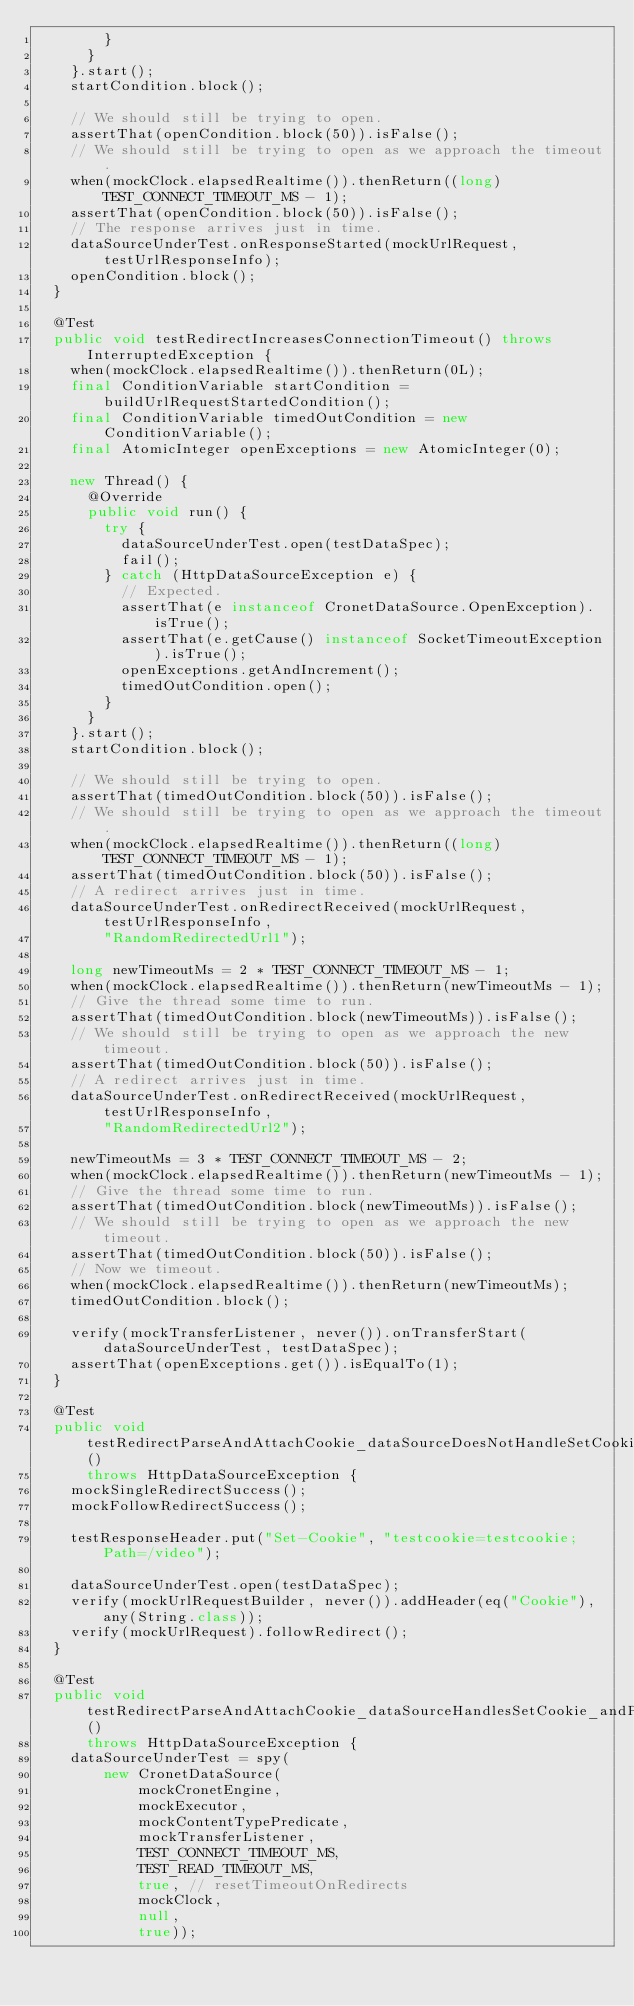Convert code to text. <code><loc_0><loc_0><loc_500><loc_500><_Java_>        }
      }
    }.start();
    startCondition.block();

    // We should still be trying to open.
    assertThat(openCondition.block(50)).isFalse();
    // We should still be trying to open as we approach the timeout.
    when(mockClock.elapsedRealtime()).thenReturn((long) TEST_CONNECT_TIMEOUT_MS - 1);
    assertThat(openCondition.block(50)).isFalse();
    // The response arrives just in time.
    dataSourceUnderTest.onResponseStarted(mockUrlRequest, testUrlResponseInfo);
    openCondition.block();
  }

  @Test
  public void testRedirectIncreasesConnectionTimeout() throws InterruptedException {
    when(mockClock.elapsedRealtime()).thenReturn(0L);
    final ConditionVariable startCondition = buildUrlRequestStartedCondition();
    final ConditionVariable timedOutCondition = new ConditionVariable();
    final AtomicInteger openExceptions = new AtomicInteger(0);

    new Thread() {
      @Override
      public void run() {
        try {
          dataSourceUnderTest.open(testDataSpec);
          fail();
        } catch (HttpDataSourceException e) {
          // Expected.
          assertThat(e instanceof CronetDataSource.OpenException).isTrue();
          assertThat(e.getCause() instanceof SocketTimeoutException).isTrue();
          openExceptions.getAndIncrement();
          timedOutCondition.open();
        }
      }
    }.start();
    startCondition.block();

    // We should still be trying to open.
    assertThat(timedOutCondition.block(50)).isFalse();
    // We should still be trying to open as we approach the timeout.
    when(mockClock.elapsedRealtime()).thenReturn((long) TEST_CONNECT_TIMEOUT_MS - 1);
    assertThat(timedOutCondition.block(50)).isFalse();
    // A redirect arrives just in time.
    dataSourceUnderTest.onRedirectReceived(mockUrlRequest, testUrlResponseInfo,
        "RandomRedirectedUrl1");

    long newTimeoutMs = 2 * TEST_CONNECT_TIMEOUT_MS - 1;
    when(mockClock.elapsedRealtime()).thenReturn(newTimeoutMs - 1);
    // Give the thread some time to run.
    assertThat(timedOutCondition.block(newTimeoutMs)).isFalse();
    // We should still be trying to open as we approach the new timeout.
    assertThat(timedOutCondition.block(50)).isFalse();
    // A redirect arrives just in time.
    dataSourceUnderTest.onRedirectReceived(mockUrlRequest, testUrlResponseInfo,
        "RandomRedirectedUrl2");

    newTimeoutMs = 3 * TEST_CONNECT_TIMEOUT_MS - 2;
    when(mockClock.elapsedRealtime()).thenReturn(newTimeoutMs - 1);
    // Give the thread some time to run.
    assertThat(timedOutCondition.block(newTimeoutMs)).isFalse();
    // We should still be trying to open as we approach the new timeout.
    assertThat(timedOutCondition.block(50)).isFalse();
    // Now we timeout.
    when(mockClock.elapsedRealtime()).thenReturn(newTimeoutMs);
    timedOutCondition.block();

    verify(mockTransferListener, never()).onTransferStart(dataSourceUnderTest, testDataSpec);
    assertThat(openExceptions.get()).isEqualTo(1);
  }

  @Test
  public void testRedirectParseAndAttachCookie_dataSourceDoesNotHandleSetCookie_followsRedirect()
      throws HttpDataSourceException {
    mockSingleRedirectSuccess();
    mockFollowRedirectSuccess();

    testResponseHeader.put("Set-Cookie", "testcookie=testcookie; Path=/video");

    dataSourceUnderTest.open(testDataSpec);
    verify(mockUrlRequestBuilder, never()).addHeader(eq("Cookie"), any(String.class));
    verify(mockUrlRequest).followRedirect();
  }

  @Test
  public void testRedirectParseAndAttachCookie_dataSourceHandlesSetCookie_andPreservesOriginalRequestHeaders()
      throws HttpDataSourceException {
    dataSourceUnderTest = spy(
        new CronetDataSource(
            mockCronetEngine,
            mockExecutor,
            mockContentTypePredicate,
            mockTransferListener,
            TEST_CONNECT_TIMEOUT_MS,
            TEST_READ_TIMEOUT_MS,
            true, // resetTimeoutOnRedirects
            mockClock,
            null,
            true));</code> 